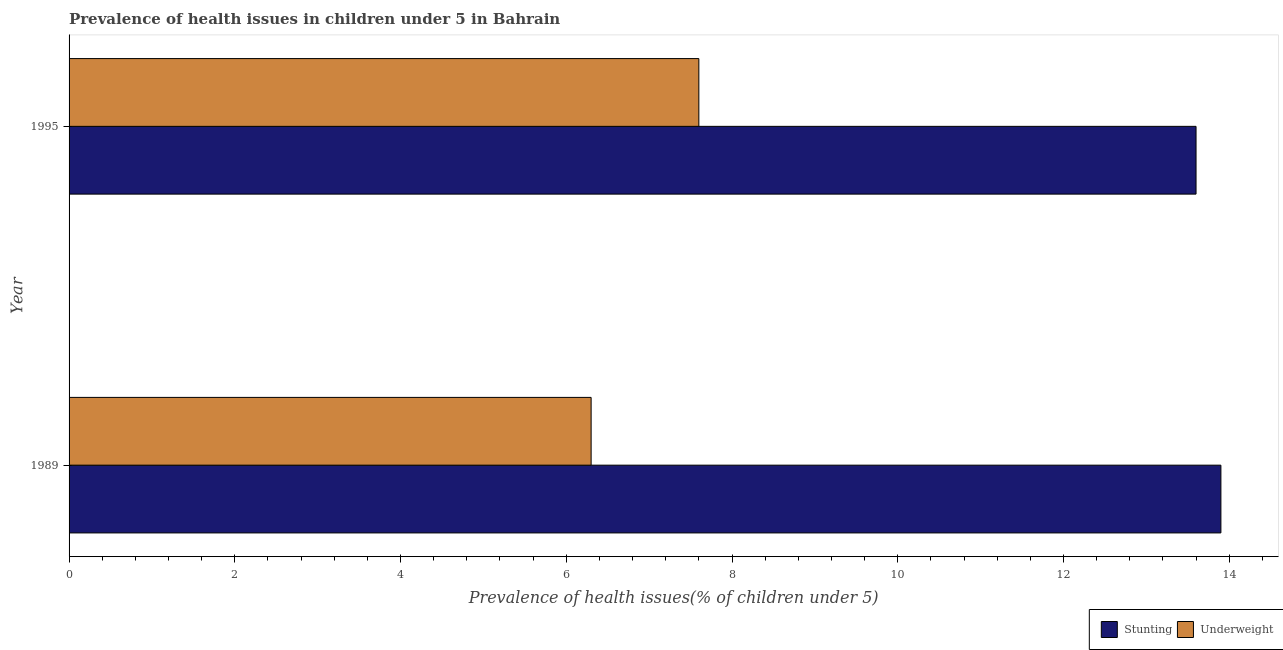Are the number of bars per tick equal to the number of legend labels?
Offer a very short reply. Yes. What is the label of the 1st group of bars from the top?
Provide a short and direct response. 1995. What is the percentage of stunted children in 1995?
Give a very brief answer. 13.6. Across all years, what is the maximum percentage of underweight children?
Keep it short and to the point. 7.6. Across all years, what is the minimum percentage of underweight children?
Ensure brevity in your answer.  6.3. What is the total percentage of underweight children in the graph?
Give a very brief answer. 13.9. What is the difference between the percentage of underweight children in 1995 and the percentage of stunted children in 1989?
Make the answer very short. -6.3. What is the average percentage of stunted children per year?
Provide a succinct answer. 13.75. What is the ratio of the percentage of stunted children in 1989 to that in 1995?
Provide a succinct answer. 1.02. In how many years, is the percentage of stunted children greater than the average percentage of stunted children taken over all years?
Give a very brief answer. 1. What does the 2nd bar from the top in 1995 represents?
Keep it short and to the point. Stunting. What does the 1st bar from the bottom in 1995 represents?
Provide a short and direct response. Stunting. How many years are there in the graph?
Provide a succinct answer. 2. Are the values on the major ticks of X-axis written in scientific E-notation?
Provide a succinct answer. No. Does the graph contain any zero values?
Keep it short and to the point. No. What is the title of the graph?
Your answer should be compact. Prevalence of health issues in children under 5 in Bahrain. What is the label or title of the X-axis?
Your answer should be compact. Prevalence of health issues(% of children under 5). What is the Prevalence of health issues(% of children under 5) of Stunting in 1989?
Provide a succinct answer. 13.9. What is the Prevalence of health issues(% of children under 5) in Underweight in 1989?
Offer a terse response. 6.3. What is the Prevalence of health issues(% of children under 5) of Stunting in 1995?
Make the answer very short. 13.6. What is the Prevalence of health issues(% of children under 5) in Underweight in 1995?
Offer a very short reply. 7.6. Across all years, what is the maximum Prevalence of health issues(% of children under 5) in Stunting?
Your answer should be compact. 13.9. Across all years, what is the maximum Prevalence of health issues(% of children under 5) of Underweight?
Offer a very short reply. 7.6. Across all years, what is the minimum Prevalence of health issues(% of children under 5) in Stunting?
Offer a terse response. 13.6. Across all years, what is the minimum Prevalence of health issues(% of children under 5) of Underweight?
Provide a succinct answer. 6.3. What is the total Prevalence of health issues(% of children under 5) in Stunting in the graph?
Provide a short and direct response. 27.5. What is the average Prevalence of health issues(% of children under 5) in Stunting per year?
Offer a terse response. 13.75. What is the average Prevalence of health issues(% of children under 5) in Underweight per year?
Offer a very short reply. 6.95. In the year 1995, what is the difference between the Prevalence of health issues(% of children under 5) in Stunting and Prevalence of health issues(% of children under 5) in Underweight?
Your response must be concise. 6. What is the ratio of the Prevalence of health issues(% of children under 5) of Stunting in 1989 to that in 1995?
Ensure brevity in your answer.  1.02. What is the ratio of the Prevalence of health issues(% of children under 5) of Underweight in 1989 to that in 1995?
Provide a short and direct response. 0.83. What is the difference between the highest and the second highest Prevalence of health issues(% of children under 5) in Stunting?
Provide a succinct answer. 0.3. 